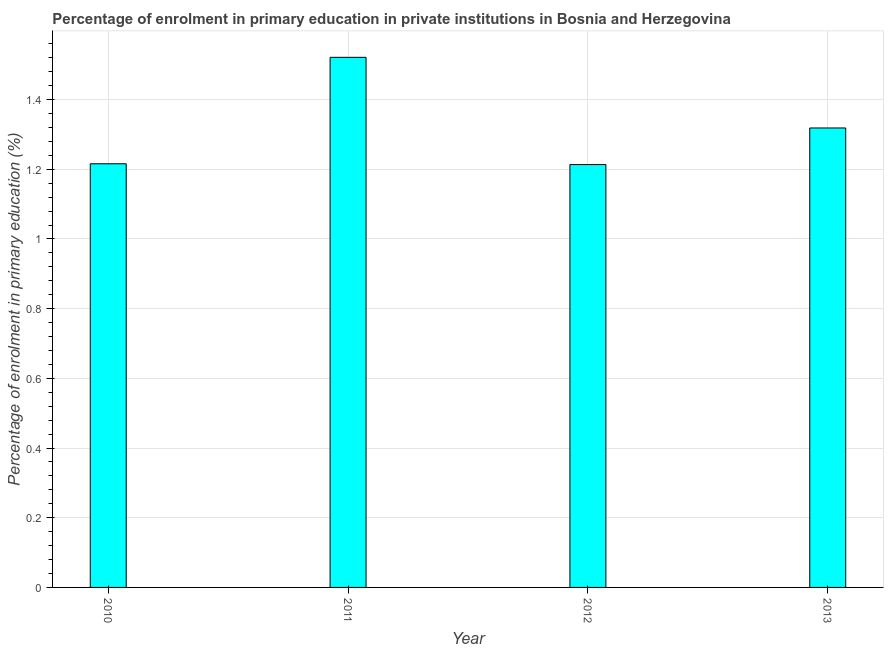Does the graph contain grids?
Provide a succinct answer. Yes. What is the title of the graph?
Your response must be concise. Percentage of enrolment in primary education in private institutions in Bosnia and Herzegovina. What is the label or title of the Y-axis?
Give a very brief answer. Percentage of enrolment in primary education (%). What is the enrolment percentage in primary education in 2012?
Your answer should be very brief. 1.21. Across all years, what is the maximum enrolment percentage in primary education?
Make the answer very short. 1.52. Across all years, what is the minimum enrolment percentage in primary education?
Make the answer very short. 1.21. In which year was the enrolment percentage in primary education maximum?
Ensure brevity in your answer.  2011. In which year was the enrolment percentage in primary education minimum?
Your answer should be compact. 2012. What is the sum of the enrolment percentage in primary education?
Provide a succinct answer. 5.27. What is the difference between the enrolment percentage in primary education in 2010 and 2013?
Provide a short and direct response. -0.1. What is the average enrolment percentage in primary education per year?
Ensure brevity in your answer.  1.32. What is the median enrolment percentage in primary education?
Give a very brief answer. 1.27. In how many years, is the enrolment percentage in primary education greater than 1.2 %?
Offer a very short reply. 4. What is the ratio of the enrolment percentage in primary education in 2011 to that in 2013?
Your answer should be very brief. 1.15. Is the enrolment percentage in primary education in 2011 less than that in 2012?
Ensure brevity in your answer.  No. Is the difference between the enrolment percentage in primary education in 2012 and 2013 greater than the difference between any two years?
Your answer should be compact. No. What is the difference between the highest and the second highest enrolment percentage in primary education?
Provide a succinct answer. 0.2. What is the difference between the highest and the lowest enrolment percentage in primary education?
Give a very brief answer. 0.31. What is the difference between two consecutive major ticks on the Y-axis?
Your answer should be compact. 0.2. What is the Percentage of enrolment in primary education (%) in 2010?
Your response must be concise. 1.22. What is the Percentage of enrolment in primary education (%) in 2011?
Give a very brief answer. 1.52. What is the Percentage of enrolment in primary education (%) in 2012?
Your response must be concise. 1.21. What is the Percentage of enrolment in primary education (%) in 2013?
Provide a succinct answer. 1.32. What is the difference between the Percentage of enrolment in primary education (%) in 2010 and 2011?
Provide a succinct answer. -0.31. What is the difference between the Percentage of enrolment in primary education (%) in 2010 and 2012?
Ensure brevity in your answer.  0. What is the difference between the Percentage of enrolment in primary education (%) in 2010 and 2013?
Provide a short and direct response. -0.1. What is the difference between the Percentage of enrolment in primary education (%) in 2011 and 2012?
Your answer should be very brief. 0.31. What is the difference between the Percentage of enrolment in primary education (%) in 2011 and 2013?
Offer a very short reply. 0.2. What is the difference between the Percentage of enrolment in primary education (%) in 2012 and 2013?
Your response must be concise. -0.1. What is the ratio of the Percentage of enrolment in primary education (%) in 2010 to that in 2011?
Offer a terse response. 0.8. What is the ratio of the Percentage of enrolment in primary education (%) in 2010 to that in 2012?
Provide a succinct answer. 1. What is the ratio of the Percentage of enrolment in primary education (%) in 2010 to that in 2013?
Keep it short and to the point. 0.92. What is the ratio of the Percentage of enrolment in primary education (%) in 2011 to that in 2012?
Ensure brevity in your answer.  1.25. What is the ratio of the Percentage of enrolment in primary education (%) in 2011 to that in 2013?
Offer a terse response. 1.15. 